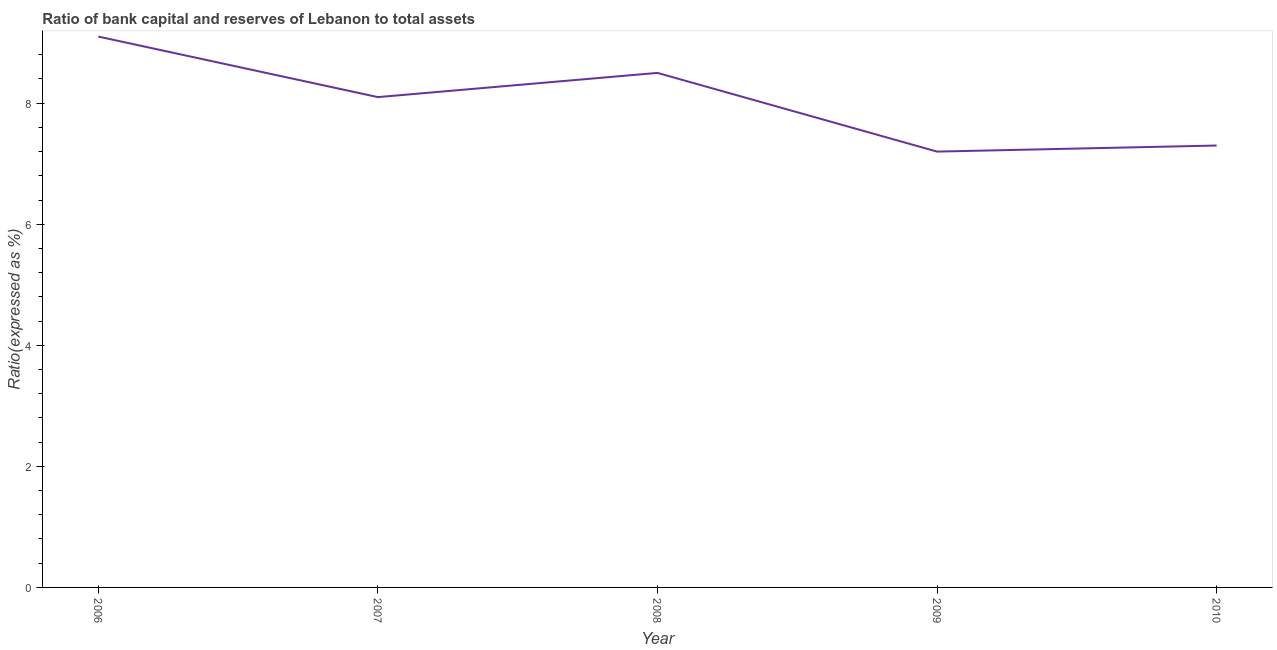Across all years, what is the minimum bank capital to assets ratio?
Offer a terse response. 7.2. What is the sum of the bank capital to assets ratio?
Offer a very short reply. 40.2. What is the difference between the bank capital to assets ratio in 2006 and 2007?
Give a very brief answer. 1. What is the average bank capital to assets ratio per year?
Your response must be concise. 8.04. What is the median bank capital to assets ratio?
Offer a very short reply. 8.1. What is the ratio of the bank capital to assets ratio in 2006 to that in 2010?
Give a very brief answer. 1.25. Is the difference between the bank capital to assets ratio in 2009 and 2010 greater than the difference between any two years?
Offer a terse response. No. What is the difference between the highest and the second highest bank capital to assets ratio?
Ensure brevity in your answer.  0.6. What is the difference between the highest and the lowest bank capital to assets ratio?
Give a very brief answer. 1.9. In how many years, is the bank capital to assets ratio greater than the average bank capital to assets ratio taken over all years?
Your answer should be compact. 3. Does the bank capital to assets ratio monotonically increase over the years?
Offer a very short reply. No. How many lines are there?
Your response must be concise. 1. What is the difference between two consecutive major ticks on the Y-axis?
Your answer should be compact. 2. Are the values on the major ticks of Y-axis written in scientific E-notation?
Your answer should be very brief. No. Does the graph contain grids?
Provide a succinct answer. No. What is the title of the graph?
Keep it short and to the point. Ratio of bank capital and reserves of Lebanon to total assets. What is the label or title of the Y-axis?
Offer a terse response. Ratio(expressed as %). What is the Ratio(expressed as %) of 2006?
Make the answer very short. 9.1. What is the Ratio(expressed as %) in 2007?
Ensure brevity in your answer.  8.1. What is the Ratio(expressed as %) in 2008?
Offer a terse response. 8.5. What is the Ratio(expressed as %) in 2010?
Your response must be concise. 7.3. What is the difference between the Ratio(expressed as %) in 2006 and 2008?
Your answer should be very brief. 0.6. What is the difference between the Ratio(expressed as %) in 2006 and 2009?
Keep it short and to the point. 1.9. What is the difference between the Ratio(expressed as %) in 2007 and 2008?
Your answer should be very brief. -0.4. What is the difference between the Ratio(expressed as %) in 2007 and 2009?
Your answer should be compact. 0.9. What is the ratio of the Ratio(expressed as %) in 2006 to that in 2007?
Keep it short and to the point. 1.12. What is the ratio of the Ratio(expressed as %) in 2006 to that in 2008?
Provide a short and direct response. 1.07. What is the ratio of the Ratio(expressed as %) in 2006 to that in 2009?
Offer a very short reply. 1.26. What is the ratio of the Ratio(expressed as %) in 2006 to that in 2010?
Ensure brevity in your answer.  1.25. What is the ratio of the Ratio(expressed as %) in 2007 to that in 2008?
Your answer should be compact. 0.95. What is the ratio of the Ratio(expressed as %) in 2007 to that in 2010?
Your response must be concise. 1.11. What is the ratio of the Ratio(expressed as %) in 2008 to that in 2009?
Provide a succinct answer. 1.18. What is the ratio of the Ratio(expressed as %) in 2008 to that in 2010?
Offer a terse response. 1.16. What is the ratio of the Ratio(expressed as %) in 2009 to that in 2010?
Offer a terse response. 0.99. 